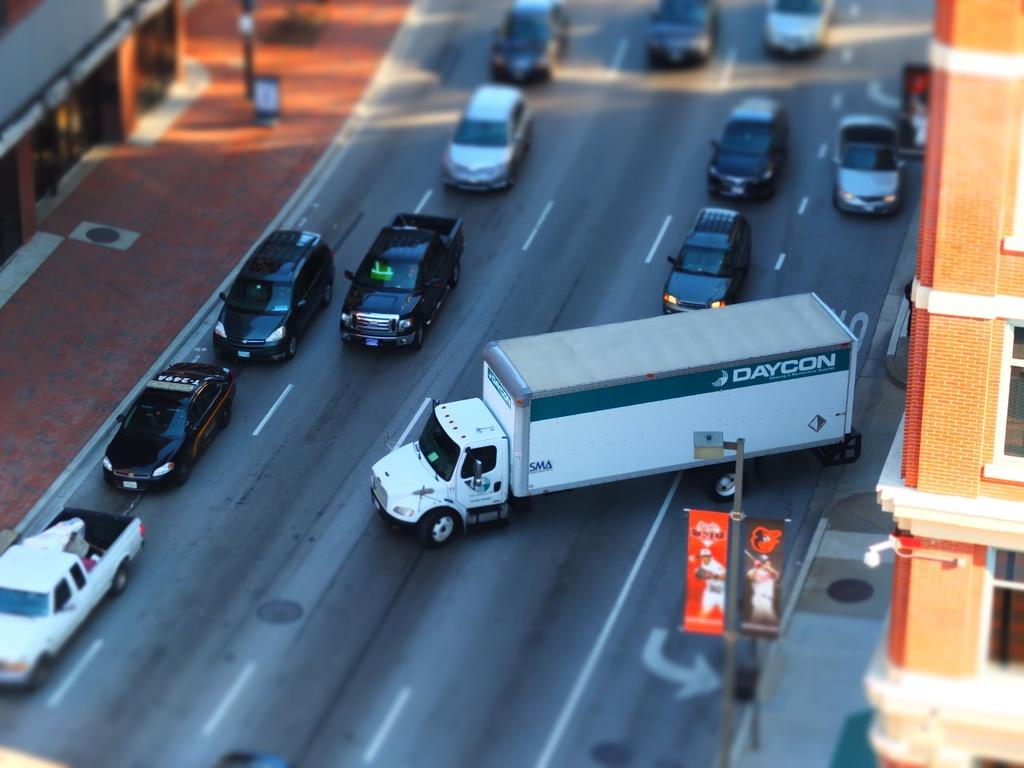What type of vehicles can be seen on the road in the image? There are cars and a truck on the road in the image. What else is present in the image besides vehicles? Banners and poles are visible in the image. Is there a designated area for pedestrians in the image? Yes, there is a footpath in the image. What can be seen in the background of the image? Buildings with windows are visible in the background of the image. How many deer can be seen in the image? There are no deer present in the image. What type of beetle is crawling on the truck in the image? There is no beetle visible on the truck in the image. 